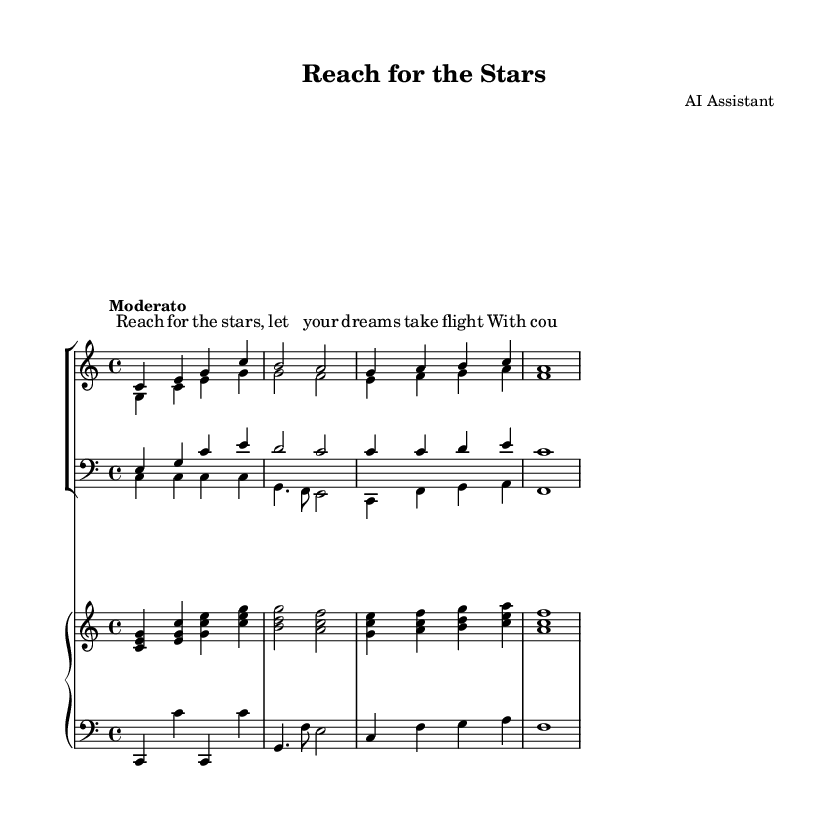What is the key signature of this music? The key signature is C major, which has no sharps or flats.
Answer: C major What is the time signature? The time signature is indicated at the beginning of the score, showing 4 beats per measure.
Answer: 4/4 What is the tempo marking for the piece? The tempo marking is "Moderato," which indicates a moderate speed.
Answer: Moderato How many vocal parts are present in this opera chorus? There are four vocal parts: soprano, alto, tenor, and bass.
Answer: Four What is the lyrical theme of the verse? The verse speaks about reaching for dreams and having the courage to pursue them.
Answer: Reaching for dreams Which two vocal sections have their lyrics aligned above their notes? The lyrics are aligned above the soprano and alto parts.
Answer: Soprano and alto 